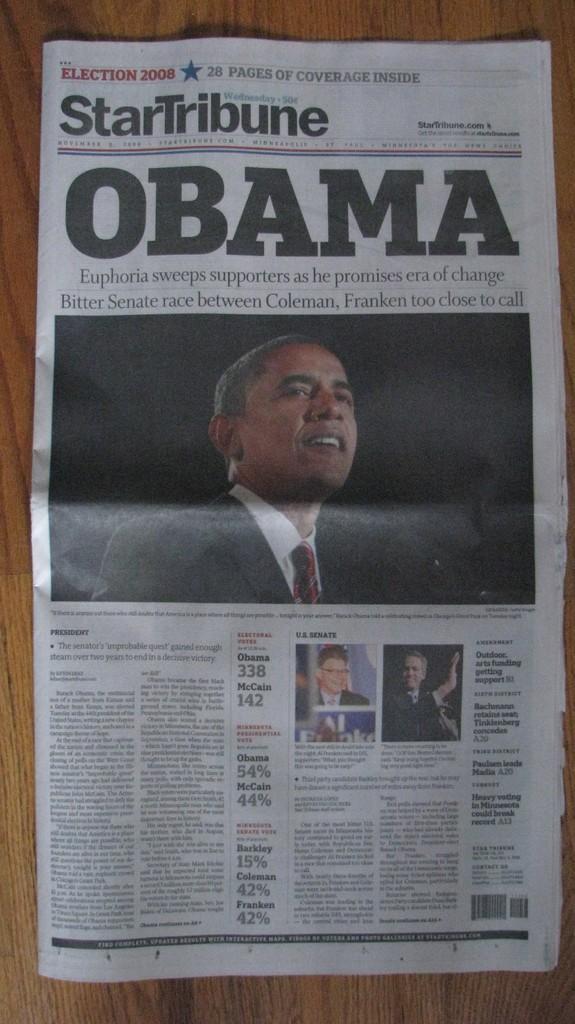In one or two sentences, can you explain what this image depicts? In this image there is a news paper having few picture of few persons wearing suit and tie. There is some text on the paper. 